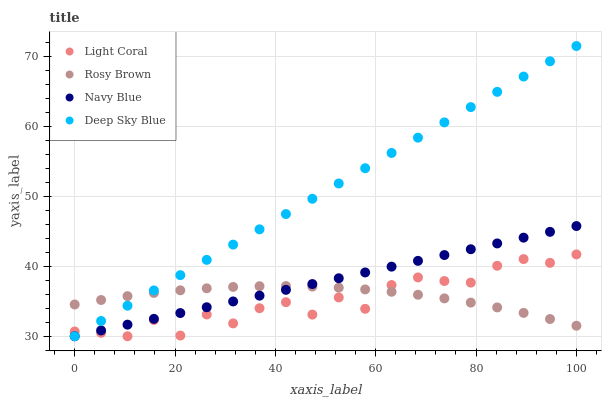Does Light Coral have the minimum area under the curve?
Answer yes or no. Yes. Does Deep Sky Blue have the maximum area under the curve?
Answer yes or no. Yes. Does Navy Blue have the minimum area under the curve?
Answer yes or no. No. Does Navy Blue have the maximum area under the curve?
Answer yes or no. No. Is Navy Blue the smoothest?
Answer yes or no. Yes. Is Light Coral the roughest?
Answer yes or no. Yes. Is Rosy Brown the smoothest?
Answer yes or no. No. Is Rosy Brown the roughest?
Answer yes or no. No. Does Light Coral have the lowest value?
Answer yes or no. Yes. Does Rosy Brown have the lowest value?
Answer yes or no. No. Does Deep Sky Blue have the highest value?
Answer yes or no. Yes. Does Navy Blue have the highest value?
Answer yes or no. No. Does Light Coral intersect Deep Sky Blue?
Answer yes or no. Yes. Is Light Coral less than Deep Sky Blue?
Answer yes or no. No. Is Light Coral greater than Deep Sky Blue?
Answer yes or no. No. 